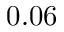<formula> <loc_0><loc_0><loc_500><loc_500>0 . 0 6</formula> 